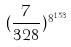<formula> <loc_0><loc_0><loc_500><loc_500>( \frac { 7 } { 3 2 8 } ) ^ { 8 ^ { 1 5 3 } }</formula> 